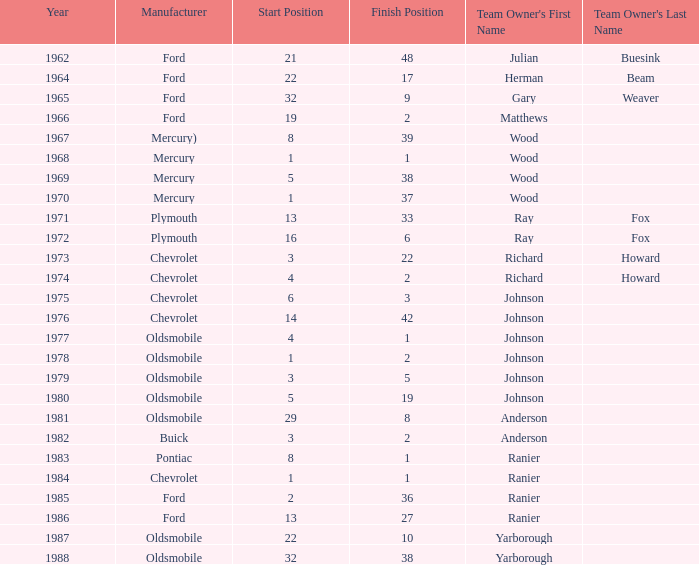Who was the maufacturer of the vehicle during the race where Cale Yarborough started at 19 and finished earlier than 42? Ford. 